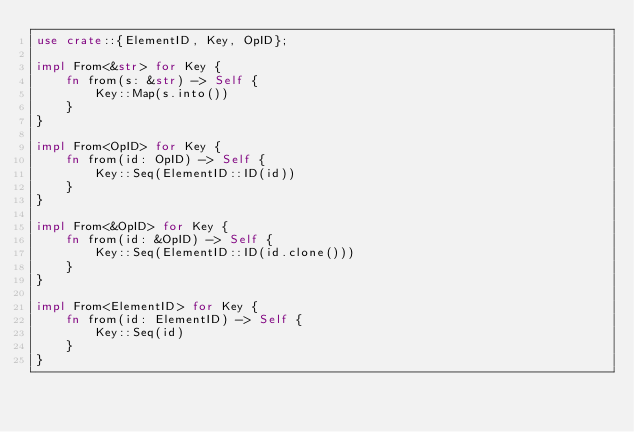<code> <loc_0><loc_0><loc_500><loc_500><_Rust_>use crate::{ElementID, Key, OpID};

impl From<&str> for Key {
    fn from(s: &str) -> Self {
        Key::Map(s.into())
    }
}

impl From<OpID> for Key {
    fn from(id: OpID) -> Self {
        Key::Seq(ElementID::ID(id))
    }
}

impl From<&OpID> for Key {
    fn from(id: &OpID) -> Self {
        Key::Seq(ElementID::ID(id.clone()))
    }
}

impl From<ElementID> for Key {
    fn from(id: ElementID) -> Self {
        Key::Seq(id)
    }
}
</code> 